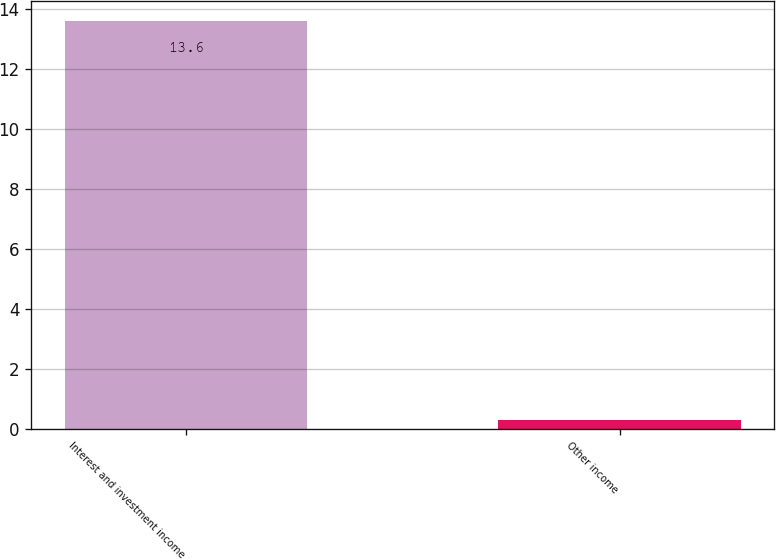Convert chart. <chart><loc_0><loc_0><loc_500><loc_500><bar_chart><fcel>Interest and investment income<fcel>Other income<nl><fcel>13.6<fcel>0.3<nl></chart> 